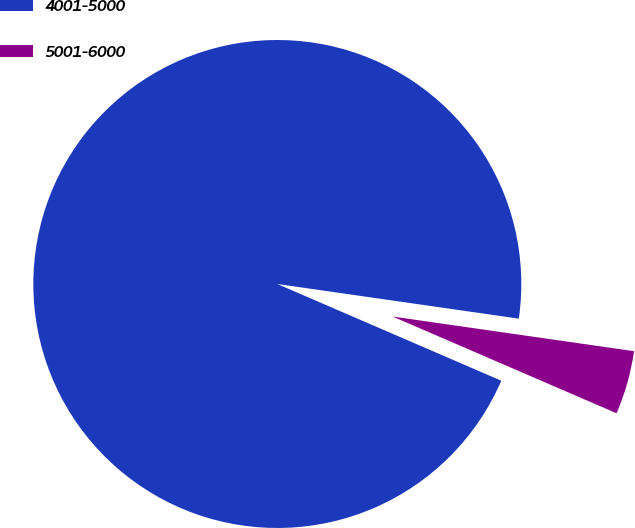Convert chart to OTSL. <chart><loc_0><loc_0><loc_500><loc_500><pie_chart><fcel>4001-5000<fcel>5001-6000<nl><fcel>95.78%<fcel>4.22%<nl></chart> 